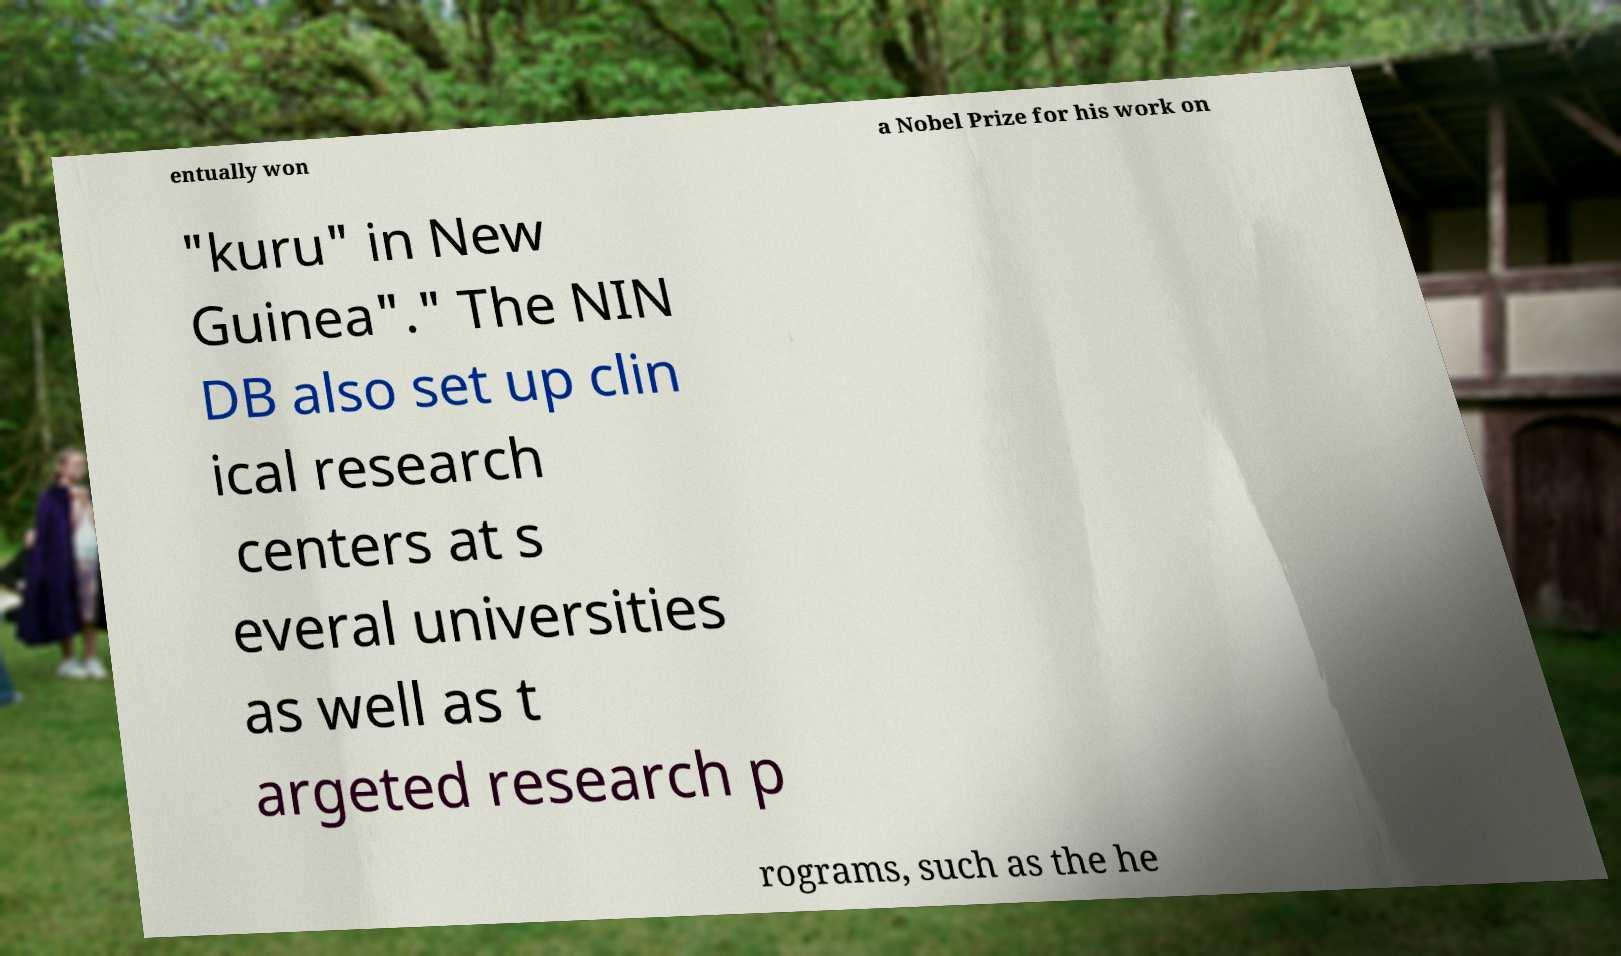For documentation purposes, I need the text within this image transcribed. Could you provide that? entually won a Nobel Prize for his work on "kuru" in New Guinea"." The NIN DB also set up clin ical research centers at s everal universities as well as t argeted research p rograms, such as the he 